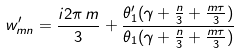<formula> <loc_0><loc_0><loc_500><loc_500>w _ { m n } ^ { \prime } = \frac { i 2 \pi \, m } { 3 } + \frac { \theta _ { 1 } ^ { \prime } ( \gamma + \frac { n } { 3 } + \frac { m \tau } { 3 } ) } { \theta _ { 1 } ( \gamma + \frac { n } { 3 } + \frac { m \tau } { 3 } ) }</formula> 